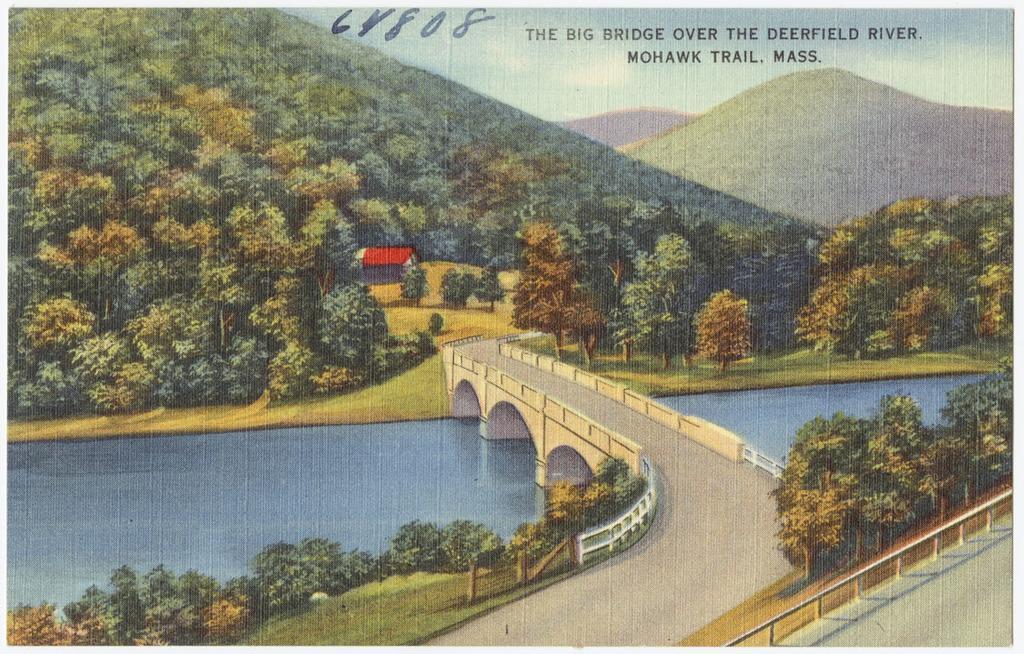Can you describe this image briefly? At the bottom we can see trees,grass,fence and a road and we can also see water and a bridge. In the background we can see trees,grass,house,mountains and clouds in the sky. At the top we can see some text written on it. 